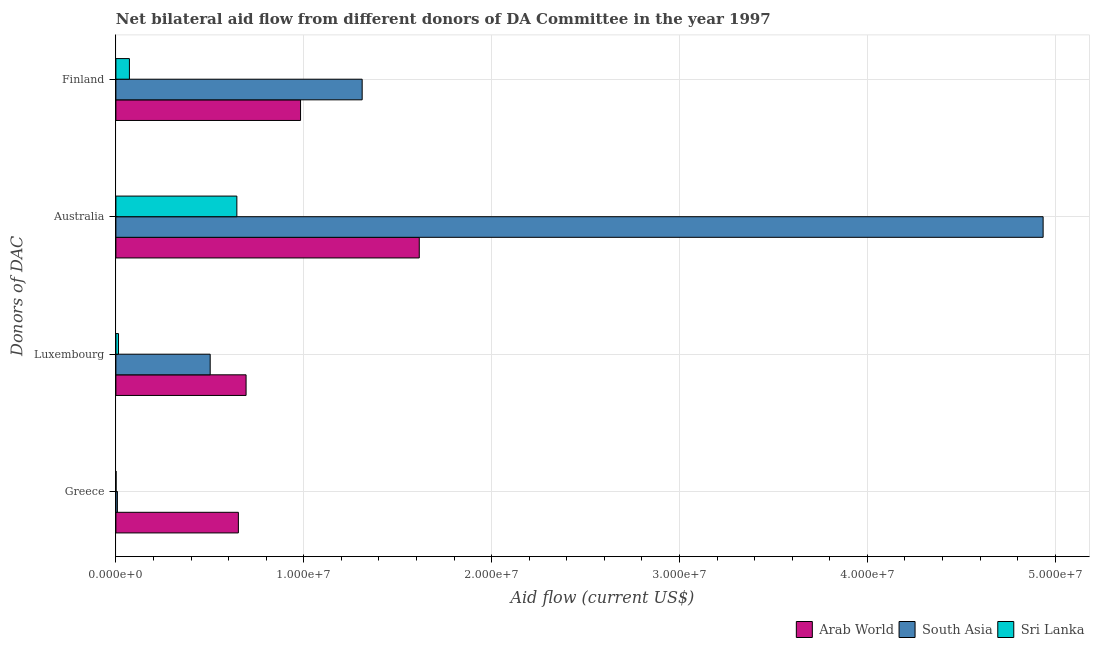Are the number of bars per tick equal to the number of legend labels?
Offer a very short reply. Yes. Are the number of bars on each tick of the Y-axis equal?
Keep it short and to the point. Yes. What is the label of the 4th group of bars from the top?
Make the answer very short. Greece. What is the amount of aid given by greece in Sri Lanka?
Offer a terse response. 10000. Across all countries, what is the maximum amount of aid given by luxembourg?
Your answer should be compact. 6.93e+06. Across all countries, what is the minimum amount of aid given by australia?
Offer a terse response. 6.44e+06. In which country was the amount of aid given by luxembourg maximum?
Give a very brief answer. Arab World. In which country was the amount of aid given by australia minimum?
Ensure brevity in your answer.  Sri Lanka. What is the total amount of aid given by australia in the graph?
Ensure brevity in your answer.  7.20e+07. What is the difference between the amount of aid given by luxembourg in Arab World and that in Sri Lanka?
Your response must be concise. 6.79e+06. What is the difference between the amount of aid given by australia in Arab World and the amount of aid given by finland in Sri Lanka?
Keep it short and to the point. 1.54e+07. What is the average amount of aid given by finland per country?
Your answer should be compact. 7.89e+06. What is the difference between the amount of aid given by luxembourg and amount of aid given by australia in Sri Lanka?
Keep it short and to the point. -6.30e+06. In how many countries, is the amount of aid given by australia greater than 26000000 US$?
Offer a very short reply. 1. What is the ratio of the amount of aid given by luxembourg in Sri Lanka to that in South Asia?
Your answer should be very brief. 0.03. What is the difference between the highest and the second highest amount of aid given by luxembourg?
Give a very brief answer. 1.91e+06. What is the difference between the highest and the lowest amount of aid given by finland?
Your answer should be very brief. 1.24e+07. In how many countries, is the amount of aid given by australia greater than the average amount of aid given by australia taken over all countries?
Your answer should be compact. 1. Is the sum of the amount of aid given by finland in Sri Lanka and Arab World greater than the maximum amount of aid given by greece across all countries?
Provide a succinct answer. Yes. What does the 3rd bar from the top in Finland represents?
Make the answer very short. Arab World. What does the 1st bar from the bottom in Australia represents?
Keep it short and to the point. Arab World. How many bars are there?
Your answer should be compact. 12. How many countries are there in the graph?
Offer a terse response. 3. Does the graph contain any zero values?
Make the answer very short. No. Does the graph contain grids?
Make the answer very short. Yes. How are the legend labels stacked?
Make the answer very short. Horizontal. What is the title of the graph?
Provide a short and direct response. Net bilateral aid flow from different donors of DA Committee in the year 1997. Does "West Bank and Gaza" appear as one of the legend labels in the graph?
Ensure brevity in your answer.  No. What is the label or title of the Y-axis?
Your answer should be very brief. Donors of DAC. What is the Aid flow (current US$) in Arab World in Greece?
Offer a very short reply. 6.52e+06. What is the Aid flow (current US$) of South Asia in Greece?
Offer a very short reply. 8.00e+04. What is the Aid flow (current US$) in Sri Lanka in Greece?
Provide a short and direct response. 10000. What is the Aid flow (current US$) of Arab World in Luxembourg?
Your response must be concise. 6.93e+06. What is the Aid flow (current US$) of South Asia in Luxembourg?
Your answer should be compact. 5.02e+06. What is the Aid flow (current US$) of Arab World in Australia?
Offer a terse response. 1.62e+07. What is the Aid flow (current US$) of South Asia in Australia?
Provide a short and direct response. 4.94e+07. What is the Aid flow (current US$) of Sri Lanka in Australia?
Make the answer very short. 6.44e+06. What is the Aid flow (current US$) of Arab World in Finland?
Offer a terse response. 9.83e+06. What is the Aid flow (current US$) of South Asia in Finland?
Provide a short and direct response. 1.31e+07. What is the Aid flow (current US$) of Sri Lanka in Finland?
Your answer should be compact. 7.20e+05. Across all Donors of DAC, what is the maximum Aid flow (current US$) of Arab World?
Give a very brief answer. 1.62e+07. Across all Donors of DAC, what is the maximum Aid flow (current US$) in South Asia?
Your answer should be very brief. 4.94e+07. Across all Donors of DAC, what is the maximum Aid flow (current US$) of Sri Lanka?
Keep it short and to the point. 6.44e+06. Across all Donors of DAC, what is the minimum Aid flow (current US$) of Arab World?
Your answer should be compact. 6.52e+06. Across all Donors of DAC, what is the minimum Aid flow (current US$) in Sri Lanka?
Offer a very short reply. 10000. What is the total Aid flow (current US$) of Arab World in the graph?
Provide a short and direct response. 3.94e+07. What is the total Aid flow (current US$) of South Asia in the graph?
Your answer should be compact. 6.76e+07. What is the total Aid flow (current US$) in Sri Lanka in the graph?
Ensure brevity in your answer.  7.31e+06. What is the difference between the Aid flow (current US$) of Arab World in Greece and that in Luxembourg?
Give a very brief answer. -4.10e+05. What is the difference between the Aid flow (current US$) in South Asia in Greece and that in Luxembourg?
Your response must be concise. -4.94e+06. What is the difference between the Aid flow (current US$) of Arab World in Greece and that in Australia?
Make the answer very short. -9.63e+06. What is the difference between the Aid flow (current US$) in South Asia in Greece and that in Australia?
Offer a terse response. -4.93e+07. What is the difference between the Aid flow (current US$) in Sri Lanka in Greece and that in Australia?
Your response must be concise. -6.43e+06. What is the difference between the Aid flow (current US$) in Arab World in Greece and that in Finland?
Give a very brief answer. -3.31e+06. What is the difference between the Aid flow (current US$) of South Asia in Greece and that in Finland?
Your answer should be compact. -1.30e+07. What is the difference between the Aid flow (current US$) of Sri Lanka in Greece and that in Finland?
Make the answer very short. -7.10e+05. What is the difference between the Aid flow (current US$) in Arab World in Luxembourg and that in Australia?
Your response must be concise. -9.22e+06. What is the difference between the Aid flow (current US$) in South Asia in Luxembourg and that in Australia?
Your response must be concise. -4.43e+07. What is the difference between the Aid flow (current US$) of Sri Lanka in Luxembourg and that in Australia?
Your answer should be compact. -6.30e+06. What is the difference between the Aid flow (current US$) in Arab World in Luxembourg and that in Finland?
Provide a short and direct response. -2.90e+06. What is the difference between the Aid flow (current US$) of South Asia in Luxembourg and that in Finland?
Offer a terse response. -8.09e+06. What is the difference between the Aid flow (current US$) of Sri Lanka in Luxembourg and that in Finland?
Make the answer very short. -5.80e+05. What is the difference between the Aid flow (current US$) in Arab World in Australia and that in Finland?
Your response must be concise. 6.32e+06. What is the difference between the Aid flow (current US$) of South Asia in Australia and that in Finland?
Ensure brevity in your answer.  3.62e+07. What is the difference between the Aid flow (current US$) in Sri Lanka in Australia and that in Finland?
Your answer should be compact. 5.72e+06. What is the difference between the Aid flow (current US$) of Arab World in Greece and the Aid flow (current US$) of South Asia in Luxembourg?
Ensure brevity in your answer.  1.50e+06. What is the difference between the Aid flow (current US$) in Arab World in Greece and the Aid flow (current US$) in Sri Lanka in Luxembourg?
Ensure brevity in your answer.  6.38e+06. What is the difference between the Aid flow (current US$) in Arab World in Greece and the Aid flow (current US$) in South Asia in Australia?
Provide a succinct answer. -4.28e+07. What is the difference between the Aid flow (current US$) of South Asia in Greece and the Aid flow (current US$) of Sri Lanka in Australia?
Make the answer very short. -6.36e+06. What is the difference between the Aid flow (current US$) of Arab World in Greece and the Aid flow (current US$) of South Asia in Finland?
Offer a terse response. -6.59e+06. What is the difference between the Aid flow (current US$) of Arab World in Greece and the Aid flow (current US$) of Sri Lanka in Finland?
Your answer should be compact. 5.80e+06. What is the difference between the Aid flow (current US$) of South Asia in Greece and the Aid flow (current US$) of Sri Lanka in Finland?
Give a very brief answer. -6.40e+05. What is the difference between the Aid flow (current US$) in Arab World in Luxembourg and the Aid flow (current US$) in South Asia in Australia?
Keep it short and to the point. -4.24e+07. What is the difference between the Aid flow (current US$) in Arab World in Luxembourg and the Aid flow (current US$) in Sri Lanka in Australia?
Ensure brevity in your answer.  4.90e+05. What is the difference between the Aid flow (current US$) in South Asia in Luxembourg and the Aid flow (current US$) in Sri Lanka in Australia?
Keep it short and to the point. -1.42e+06. What is the difference between the Aid flow (current US$) of Arab World in Luxembourg and the Aid flow (current US$) of South Asia in Finland?
Provide a succinct answer. -6.18e+06. What is the difference between the Aid flow (current US$) in Arab World in Luxembourg and the Aid flow (current US$) in Sri Lanka in Finland?
Your response must be concise. 6.21e+06. What is the difference between the Aid flow (current US$) of South Asia in Luxembourg and the Aid flow (current US$) of Sri Lanka in Finland?
Provide a succinct answer. 4.30e+06. What is the difference between the Aid flow (current US$) of Arab World in Australia and the Aid flow (current US$) of South Asia in Finland?
Offer a very short reply. 3.04e+06. What is the difference between the Aid flow (current US$) of Arab World in Australia and the Aid flow (current US$) of Sri Lanka in Finland?
Provide a short and direct response. 1.54e+07. What is the difference between the Aid flow (current US$) of South Asia in Australia and the Aid flow (current US$) of Sri Lanka in Finland?
Your answer should be very brief. 4.86e+07. What is the average Aid flow (current US$) of Arab World per Donors of DAC?
Ensure brevity in your answer.  9.86e+06. What is the average Aid flow (current US$) of South Asia per Donors of DAC?
Offer a very short reply. 1.69e+07. What is the average Aid flow (current US$) of Sri Lanka per Donors of DAC?
Make the answer very short. 1.83e+06. What is the difference between the Aid flow (current US$) of Arab World and Aid flow (current US$) of South Asia in Greece?
Give a very brief answer. 6.44e+06. What is the difference between the Aid flow (current US$) of Arab World and Aid flow (current US$) of Sri Lanka in Greece?
Make the answer very short. 6.51e+06. What is the difference between the Aid flow (current US$) of Arab World and Aid flow (current US$) of South Asia in Luxembourg?
Make the answer very short. 1.91e+06. What is the difference between the Aid flow (current US$) of Arab World and Aid flow (current US$) of Sri Lanka in Luxembourg?
Provide a succinct answer. 6.79e+06. What is the difference between the Aid flow (current US$) of South Asia and Aid flow (current US$) of Sri Lanka in Luxembourg?
Give a very brief answer. 4.88e+06. What is the difference between the Aid flow (current US$) of Arab World and Aid flow (current US$) of South Asia in Australia?
Your response must be concise. -3.32e+07. What is the difference between the Aid flow (current US$) in Arab World and Aid flow (current US$) in Sri Lanka in Australia?
Give a very brief answer. 9.71e+06. What is the difference between the Aid flow (current US$) of South Asia and Aid flow (current US$) of Sri Lanka in Australia?
Offer a terse response. 4.29e+07. What is the difference between the Aid flow (current US$) of Arab World and Aid flow (current US$) of South Asia in Finland?
Your response must be concise. -3.28e+06. What is the difference between the Aid flow (current US$) of Arab World and Aid flow (current US$) of Sri Lanka in Finland?
Your answer should be compact. 9.11e+06. What is the difference between the Aid flow (current US$) of South Asia and Aid flow (current US$) of Sri Lanka in Finland?
Your answer should be compact. 1.24e+07. What is the ratio of the Aid flow (current US$) of Arab World in Greece to that in Luxembourg?
Give a very brief answer. 0.94. What is the ratio of the Aid flow (current US$) in South Asia in Greece to that in Luxembourg?
Ensure brevity in your answer.  0.02. What is the ratio of the Aid flow (current US$) of Sri Lanka in Greece to that in Luxembourg?
Offer a very short reply. 0.07. What is the ratio of the Aid flow (current US$) in Arab World in Greece to that in Australia?
Your response must be concise. 0.4. What is the ratio of the Aid flow (current US$) of South Asia in Greece to that in Australia?
Ensure brevity in your answer.  0. What is the ratio of the Aid flow (current US$) of Sri Lanka in Greece to that in Australia?
Keep it short and to the point. 0. What is the ratio of the Aid flow (current US$) in Arab World in Greece to that in Finland?
Give a very brief answer. 0.66. What is the ratio of the Aid flow (current US$) of South Asia in Greece to that in Finland?
Your answer should be compact. 0.01. What is the ratio of the Aid flow (current US$) of Sri Lanka in Greece to that in Finland?
Your answer should be compact. 0.01. What is the ratio of the Aid flow (current US$) of Arab World in Luxembourg to that in Australia?
Provide a succinct answer. 0.43. What is the ratio of the Aid flow (current US$) of South Asia in Luxembourg to that in Australia?
Offer a terse response. 0.1. What is the ratio of the Aid flow (current US$) in Sri Lanka in Luxembourg to that in Australia?
Your response must be concise. 0.02. What is the ratio of the Aid flow (current US$) of Arab World in Luxembourg to that in Finland?
Your answer should be very brief. 0.7. What is the ratio of the Aid flow (current US$) in South Asia in Luxembourg to that in Finland?
Provide a short and direct response. 0.38. What is the ratio of the Aid flow (current US$) of Sri Lanka in Luxembourg to that in Finland?
Provide a succinct answer. 0.19. What is the ratio of the Aid flow (current US$) of Arab World in Australia to that in Finland?
Your answer should be compact. 1.64. What is the ratio of the Aid flow (current US$) of South Asia in Australia to that in Finland?
Ensure brevity in your answer.  3.77. What is the ratio of the Aid flow (current US$) of Sri Lanka in Australia to that in Finland?
Your answer should be very brief. 8.94. What is the difference between the highest and the second highest Aid flow (current US$) of Arab World?
Your answer should be very brief. 6.32e+06. What is the difference between the highest and the second highest Aid flow (current US$) of South Asia?
Provide a short and direct response. 3.62e+07. What is the difference between the highest and the second highest Aid flow (current US$) in Sri Lanka?
Ensure brevity in your answer.  5.72e+06. What is the difference between the highest and the lowest Aid flow (current US$) in Arab World?
Offer a terse response. 9.63e+06. What is the difference between the highest and the lowest Aid flow (current US$) of South Asia?
Offer a terse response. 4.93e+07. What is the difference between the highest and the lowest Aid flow (current US$) of Sri Lanka?
Provide a succinct answer. 6.43e+06. 